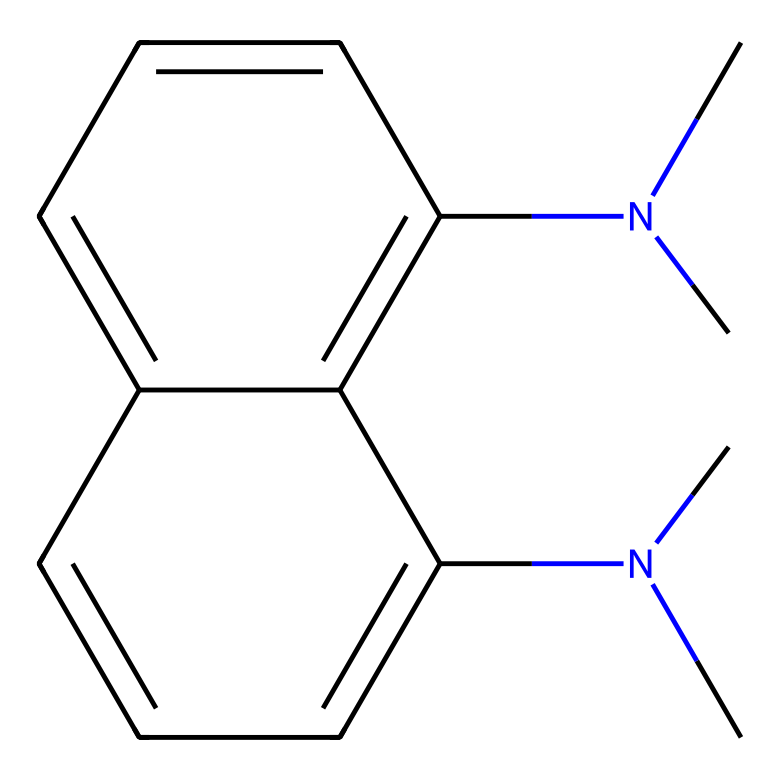What is the main functional group in 1,8-bis(dimethylamino)naphthalene? The main functional group in this chemical is the dimethylamino group, which is characterized by the presence of nitrogen bonded to two methyl groups. This can be observed in the SMILES representation where "N(C)C" appears multiple times.
Answer: dimethylamino How many aromatic rings are present in the chemical structure? The structure contains two fused aromatic rings, which can be identified by the alternating double bonds in the rings as presented in the SMILES notation.
Answer: two What is the total number of nitrogen atoms in 1,8-bis(dimethylamino)naphthalene? From the chemical structure, there are two dimethylamino groups, each containing one nitrogen atom. Thus, there are two nitrogen atoms in total as reflected in the SMILES.
Answer: two What type of base is 1,8-bis(dimethylamino)naphthalene considered? This compound is classified as a superbase due to its highly basic nature derived from the presence of the dimethylamino groups, which can readily donate a pair of electrons.
Answer: superbase Which property of this chemical allows it to be useful in dye synthesis? The presence of strong electron-donating dimethylamino groups enhances the reactivity of this compound, making it effective in dye synthesis through electrophilic aromatic substitution.
Answer: reactivity How many carbon atoms are present in the chemical structure? By counting the carbon atoms present in the structure based on the SMILES, there are 12 carbon atoms in total, deduced from the representation.
Answer: twelve 